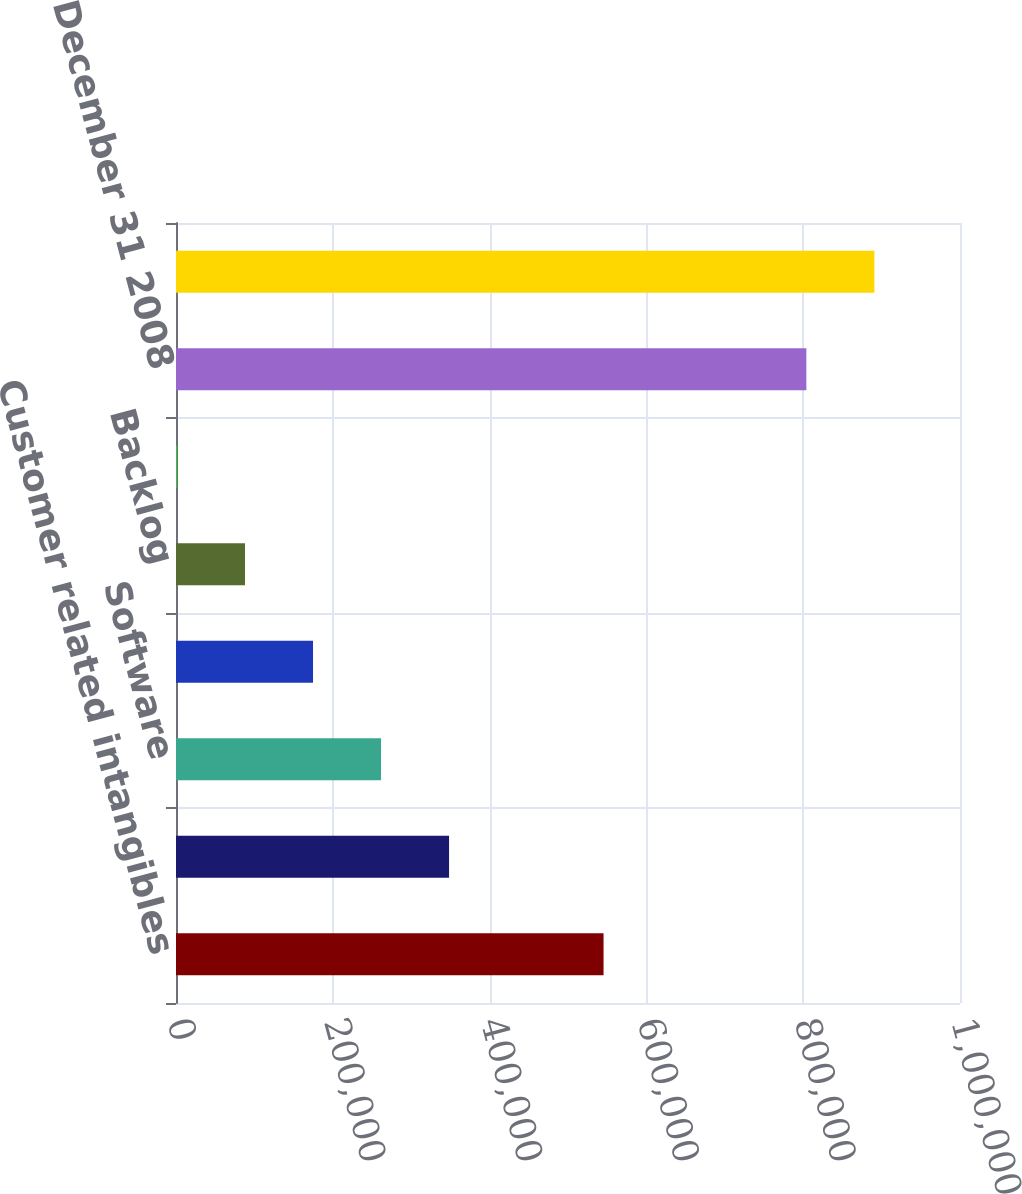Convert chart. <chart><loc_0><loc_0><loc_500><loc_500><bar_chart><fcel>Customer related intangibles<fcel>Unpatented technology<fcel>Software<fcel>Patents and other protective<fcel>Backlog<fcel>Trade secrets<fcel>Balances at December 31 2008<fcel>Balances at December 31 2009<nl><fcel>545336<fcel>348296<fcel>261528<fcel>174761<fcel>87993.4<fcel>1226<fcel>804020<fcel>890787<nl></chart> 